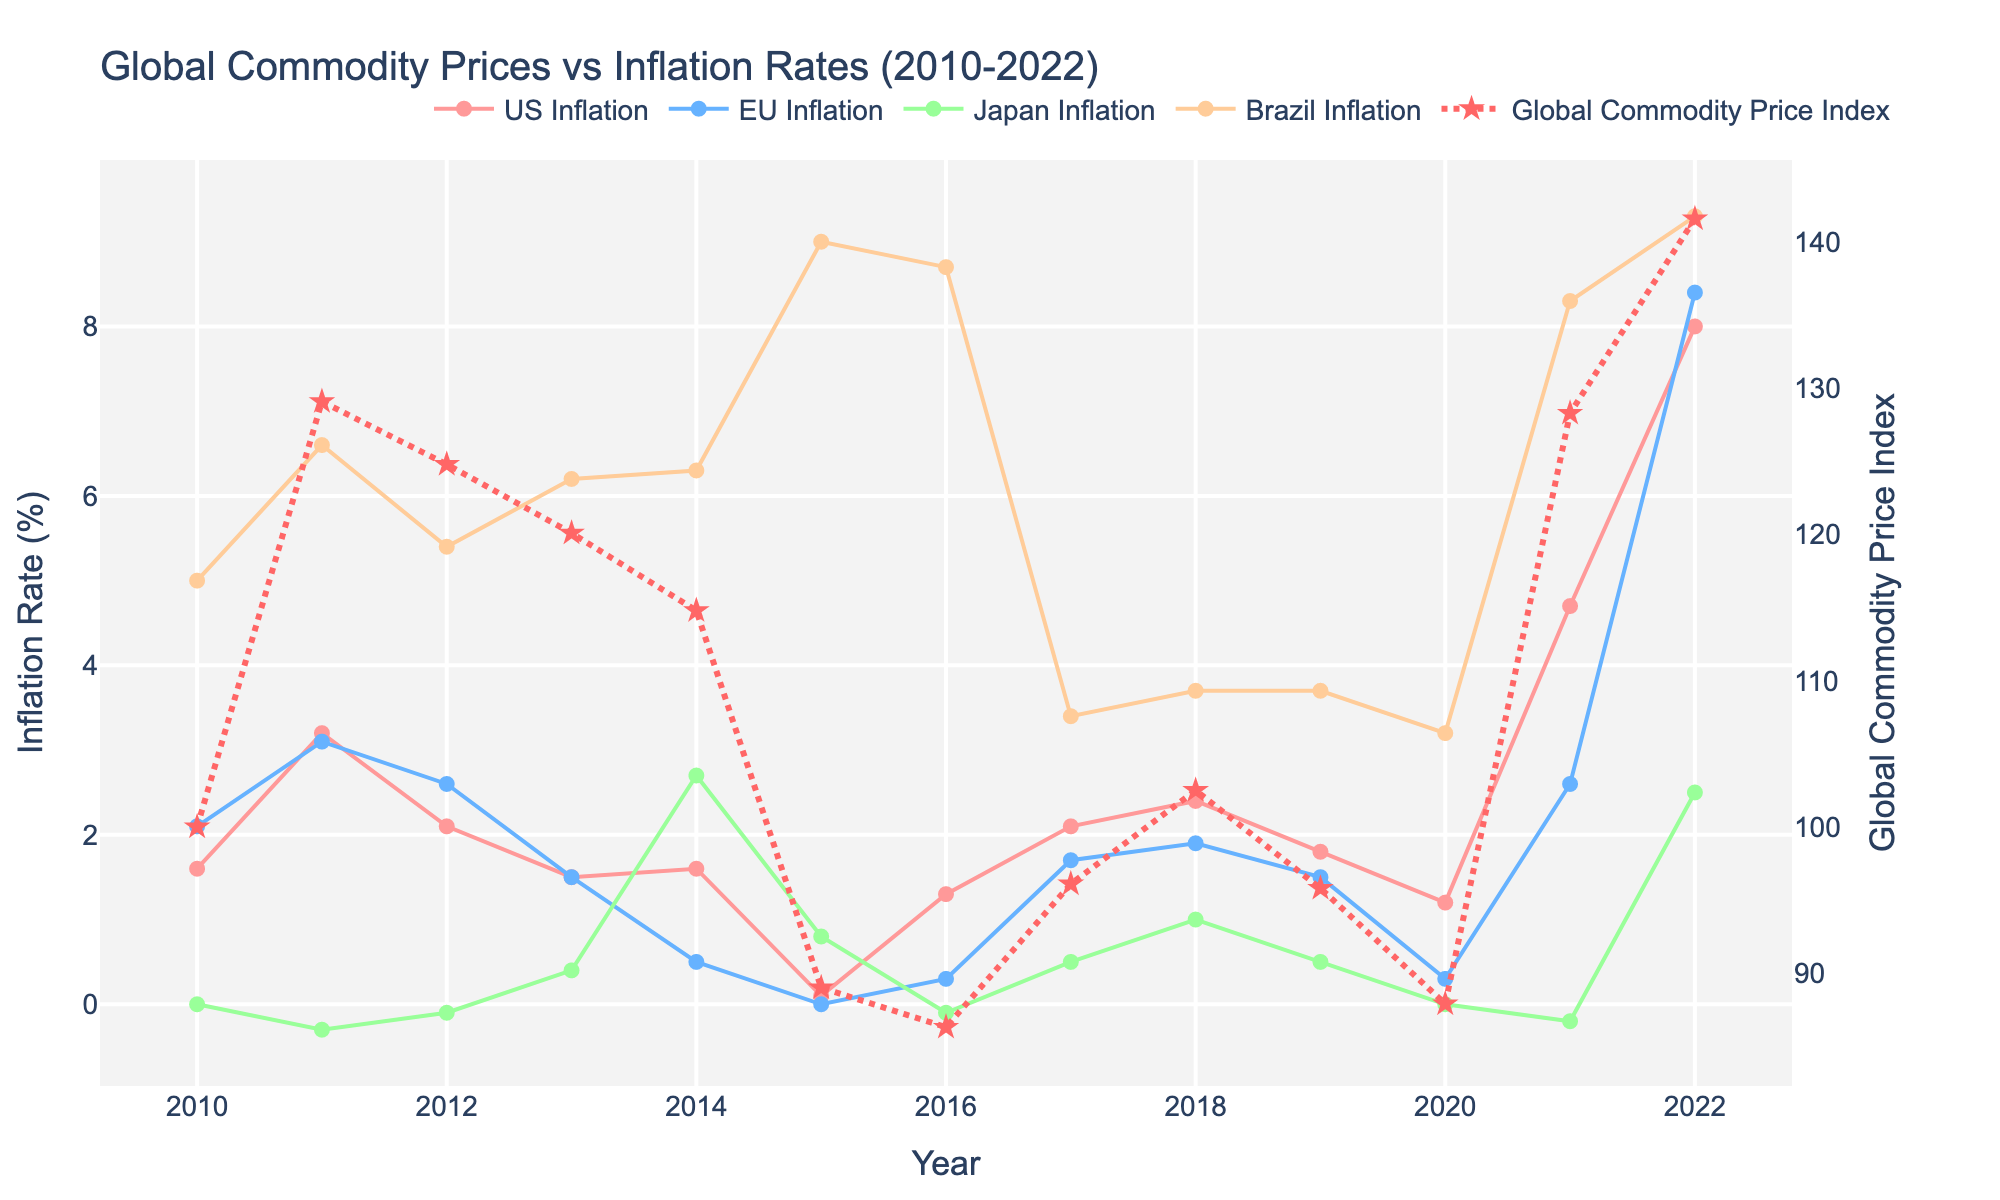what was the highest inflation rate for Brazil, and in what year did it occur? Looking at the blue line representing Brazil's inflation rate, it peaks at 9.3% in 2022
Answer: 9.3% in 2022 How does the peak of the Global Commodity Price Index compare to the US inflation rate in 2022? The Global Commodity Price Index peaks at 141.6 in 2022, while the US inflation rate for the same year is at 8.0%
Answer: Global Commodity Price Index is higher Which year shows the largest decline in the Global Commodity Price Index, and what was the percentage decrease from the previous year? Observing the red dashed line, the largest decline occurs from 2014 (114.8) to 2015 (89.0). The percentage decrease is ((114.8 - 89.0) / 114.8) * 100 ≈ 22.5%
Answer: 2015, ≈22.5% During which years did Japan experience deflation, and how many such years were there? The green line represents Japan's inflation rate, showing negative values for 2011, 2012, 2016, and 2021. There are four such years in total
Answer: 2011, 2012, 2016, 2021; 4 years In which year did both the EU and the US have the same inflation rate, and what was that rate? The inflation rate lines for EU and US intersect in 2013, where both have an inflation rate of 1.5%
Answer: 2013, 1.5% What are the years when the Global Commodity Price Index increased consecutively, and by how much did it increase from the beginning to the end of this period? The Global Commodity Price Index increased consecutively from 2016 (86.3) to 2018 (102.5). The total increase is 102.5 - 86.3 = 16.2
Answer: 2016-2018; 16.2 How does the increase in US inflation from 2020 to 2022 compare to the increase in the Global Commodity Price Index in the same period? The US inflation rate increased from 1.2% in 2020 to 8.0% in 2022, an increase of 6.8 percentage points. The Global Commodity Price Index increased from 87.9 to 141.6, an increase of 53.7. Hence, both increased but using different scales
Answer: U.S.: 6.8 percentage points, Commodity Price Index: 53.7 During what period did the EU show the lowest inflation rate, and what was the rate? The lowest inflation rate for the EU is seen in 2015 at 0.0%, represented by the purple line
Answer: 2015; 0.0% Which country had the highest variability in inflation rates across the years and how can it be visually identified? Brazil shows the highest variability in inflation rates, noticeable by the significant fluctuations in the blue line
Answer: Brazil What patterns, if any, can be observed in the relationship between global commodity prices and inflation rates in the US? Generally, when the Global Commodity Price Index increases, the US inflation rate seems to follow, such as in 2011 and 2021-2022. However, this is not always a direct correlation as seen in other years. This suggests a trend but not a strict one-to-one relationship
Answer: Generally, increases correspond 